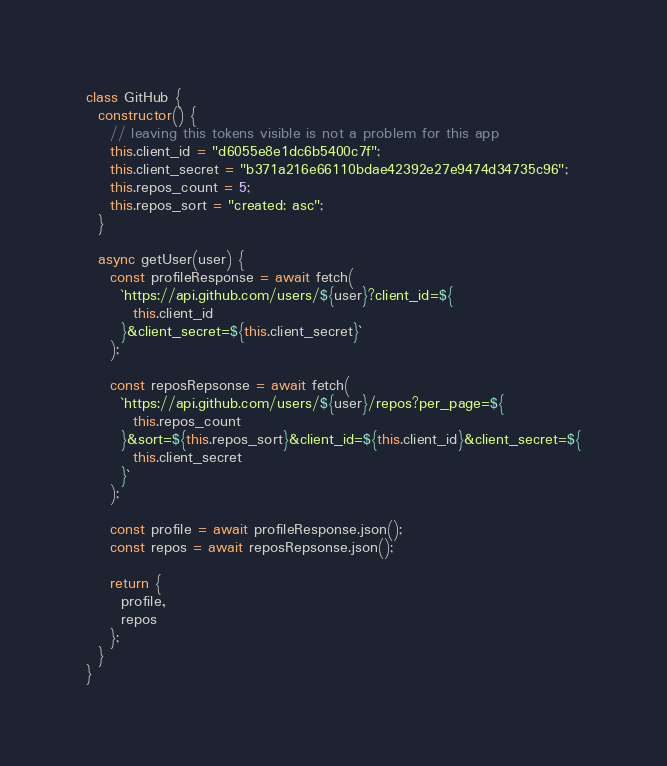Convert code to text. <code><loc_0><loc_0><loc_500><loc_500><_JavaScript_>class GitHub {
  constructor() {
    // leaving this tokens visible is not a problem for this app
    this.client_id = "d6055e8e1dc6b5400c7f";
    this.client_secret = "b371a216e66110bdae42392e27e9474d34735c96";
    this.repos_count = 5;
    this.repos_sort = "created: asc";
  }

  async getUser(user) {
    const profileResponse = await fetch(
      `https://api.github.com/users/${user}?client_id=${
        this.client_id
      }&client_secret=${this.client_secret}`
    );

    const reposRepsonse = await fetch(
      `https://api.github.com/users/${user}/repos?per_page=${
        this.repos_count
      }&sort=${this.repos_sort}&client_id=${this.client_id}&client_secret=${
        this.client_secret
      }`
    );

    const profile = await profileResponse.json();
    const repos = await reposRepsonse.json();

    return {
      profile,
      repos
    };
  }
}
</code> 